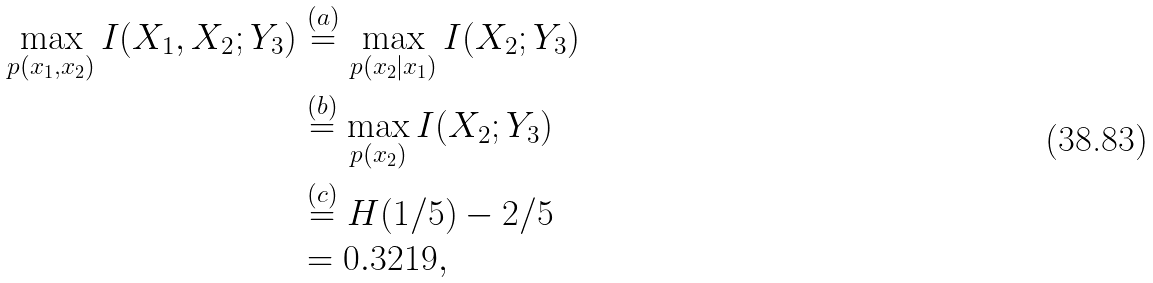Convert formula to latex. <formula><loc_0><loc_0><loc_500><loc_500>\max _ { p ( x _ { 1 } , x _ { 2 } ) } I ( X _ { 1 } , X _ { 2 } ; Y _ { 3 } ) & \stackrel { ( a ) } { = } \max _ { p ( x _ { 2 } | x _ { 1 } ) } I ( X _ { 2 } ; Y _ { 3 } ) \\ & \stackrel { ( b ) } { = } \max _ { p ( x _ { 2 } ) } I ( X _ { 2 } ; Y _ { 3 } ) \\ & \stackrel { ( c ) } { = } H ( 1 / 5 ) - 2 / 5 \\ & = 0 . 3 2 1 9 ,</formula> 